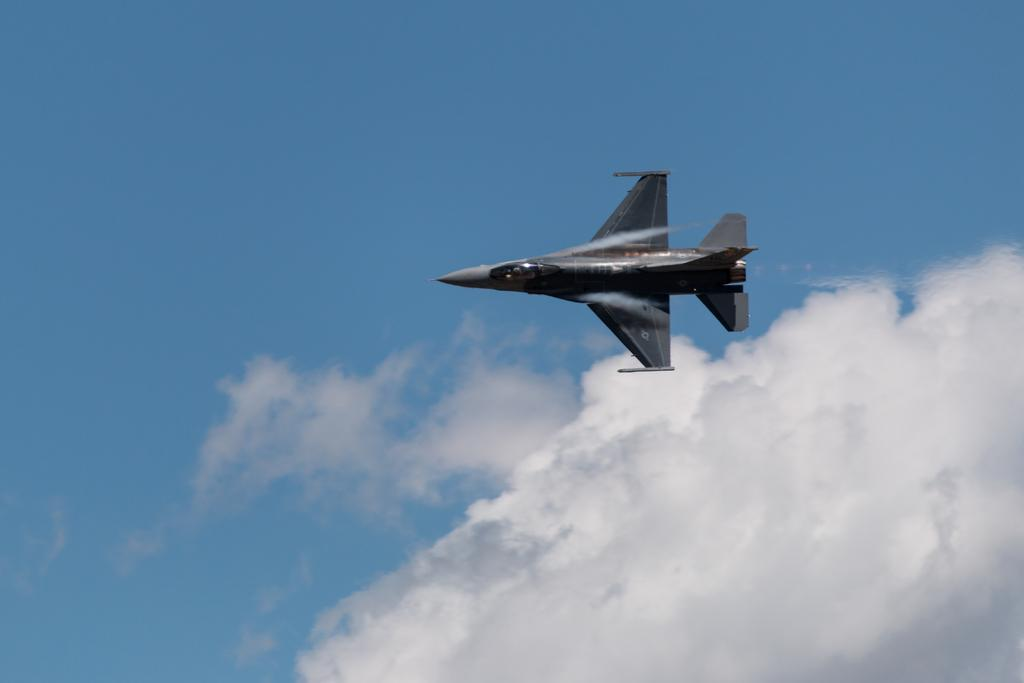What is the main subject of the image? There is an aircraft in the image. What is the aircraft doing in the image? The aircraft is flying in the air. What can be seen in the background of the image? The sky is visible in the background of the image. What is the color of the sky in the image? The sky is blue in color. What else can be observed in the sky in the image? Clouds are present in the sky. What decision does the star make in the image? There is no star present in the image, so no decision can be made by a star. 